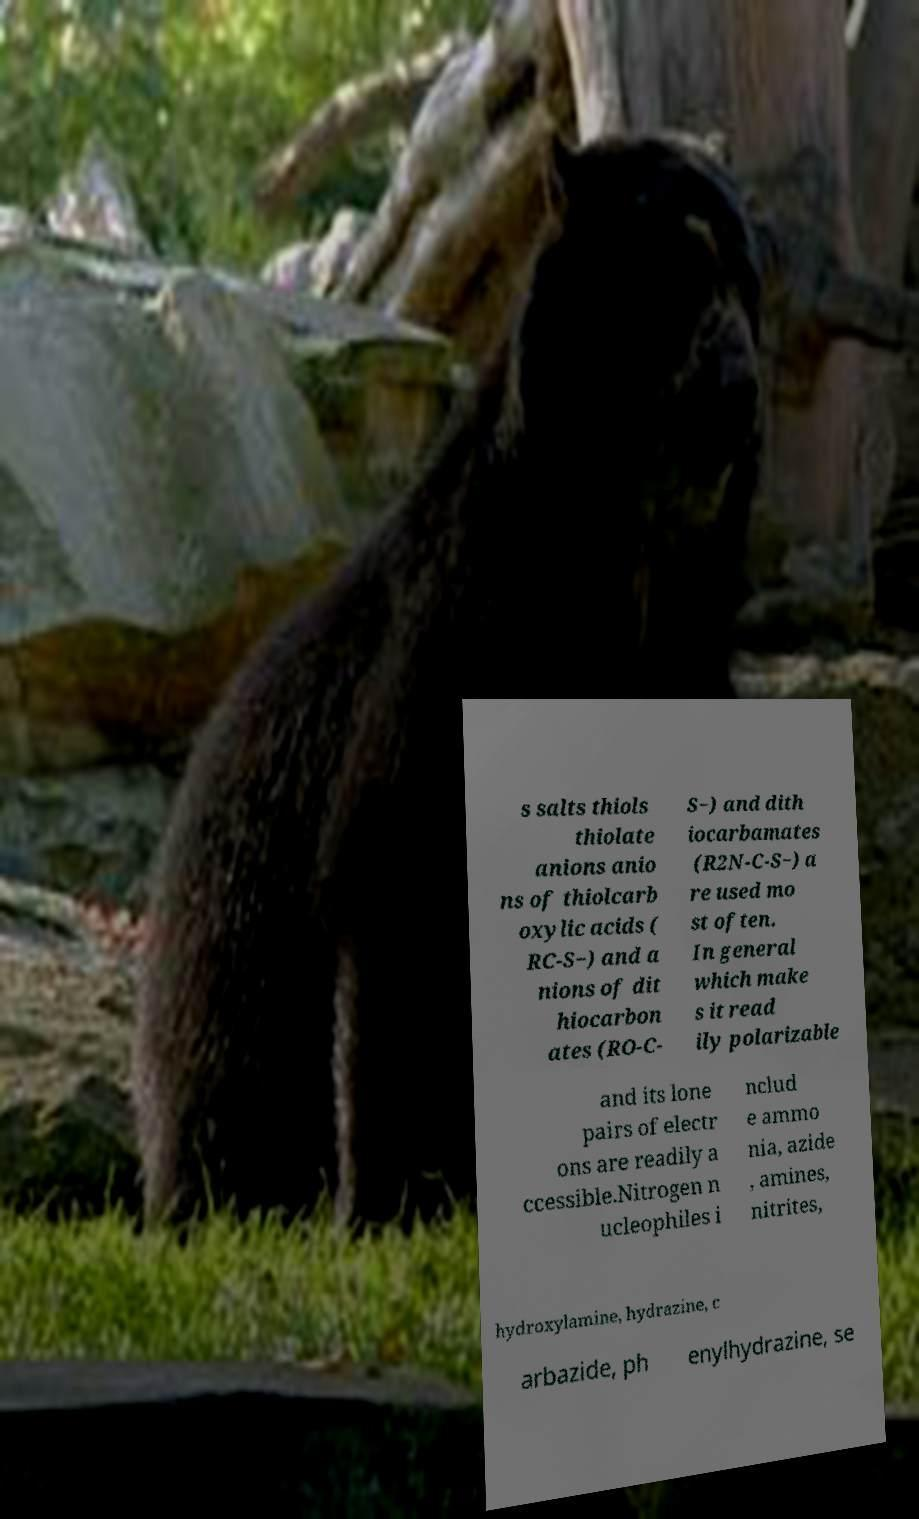Can you accurately transcribe the text from the provided image for me? s salts thiols thiolate anions anio ns of thiolcarb oxylic acids ( RC-S−) and a nions of dit hiocarbon ates (RO-C- S−) and dith iocarbamates (R2N-C-S−) a re used mo st often. In general which make s it read ily polarizable and its lone pairs of electr ons are readily a ccessible.Nitrogen n ucleophiles i nclud e ammo nia, azide , amines, nitrites, hydroxylamine, hydrazine, c arbazide, ph enylhydrazine, se 